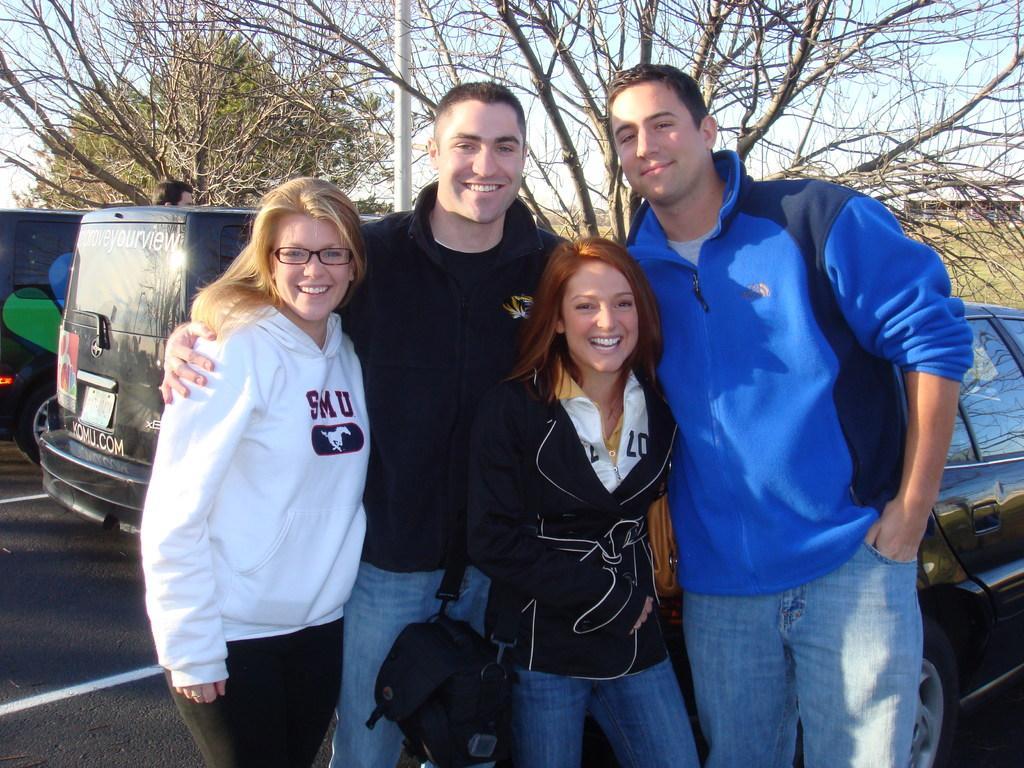How would you summarize this image in a sentence or two? In this picture there are people standing and smiling, among them there is a woman carrying a bag, behind these people we can see vehicles on the road, pole, person's head and trees. In the background of the image we can see wall, grass and sky. 